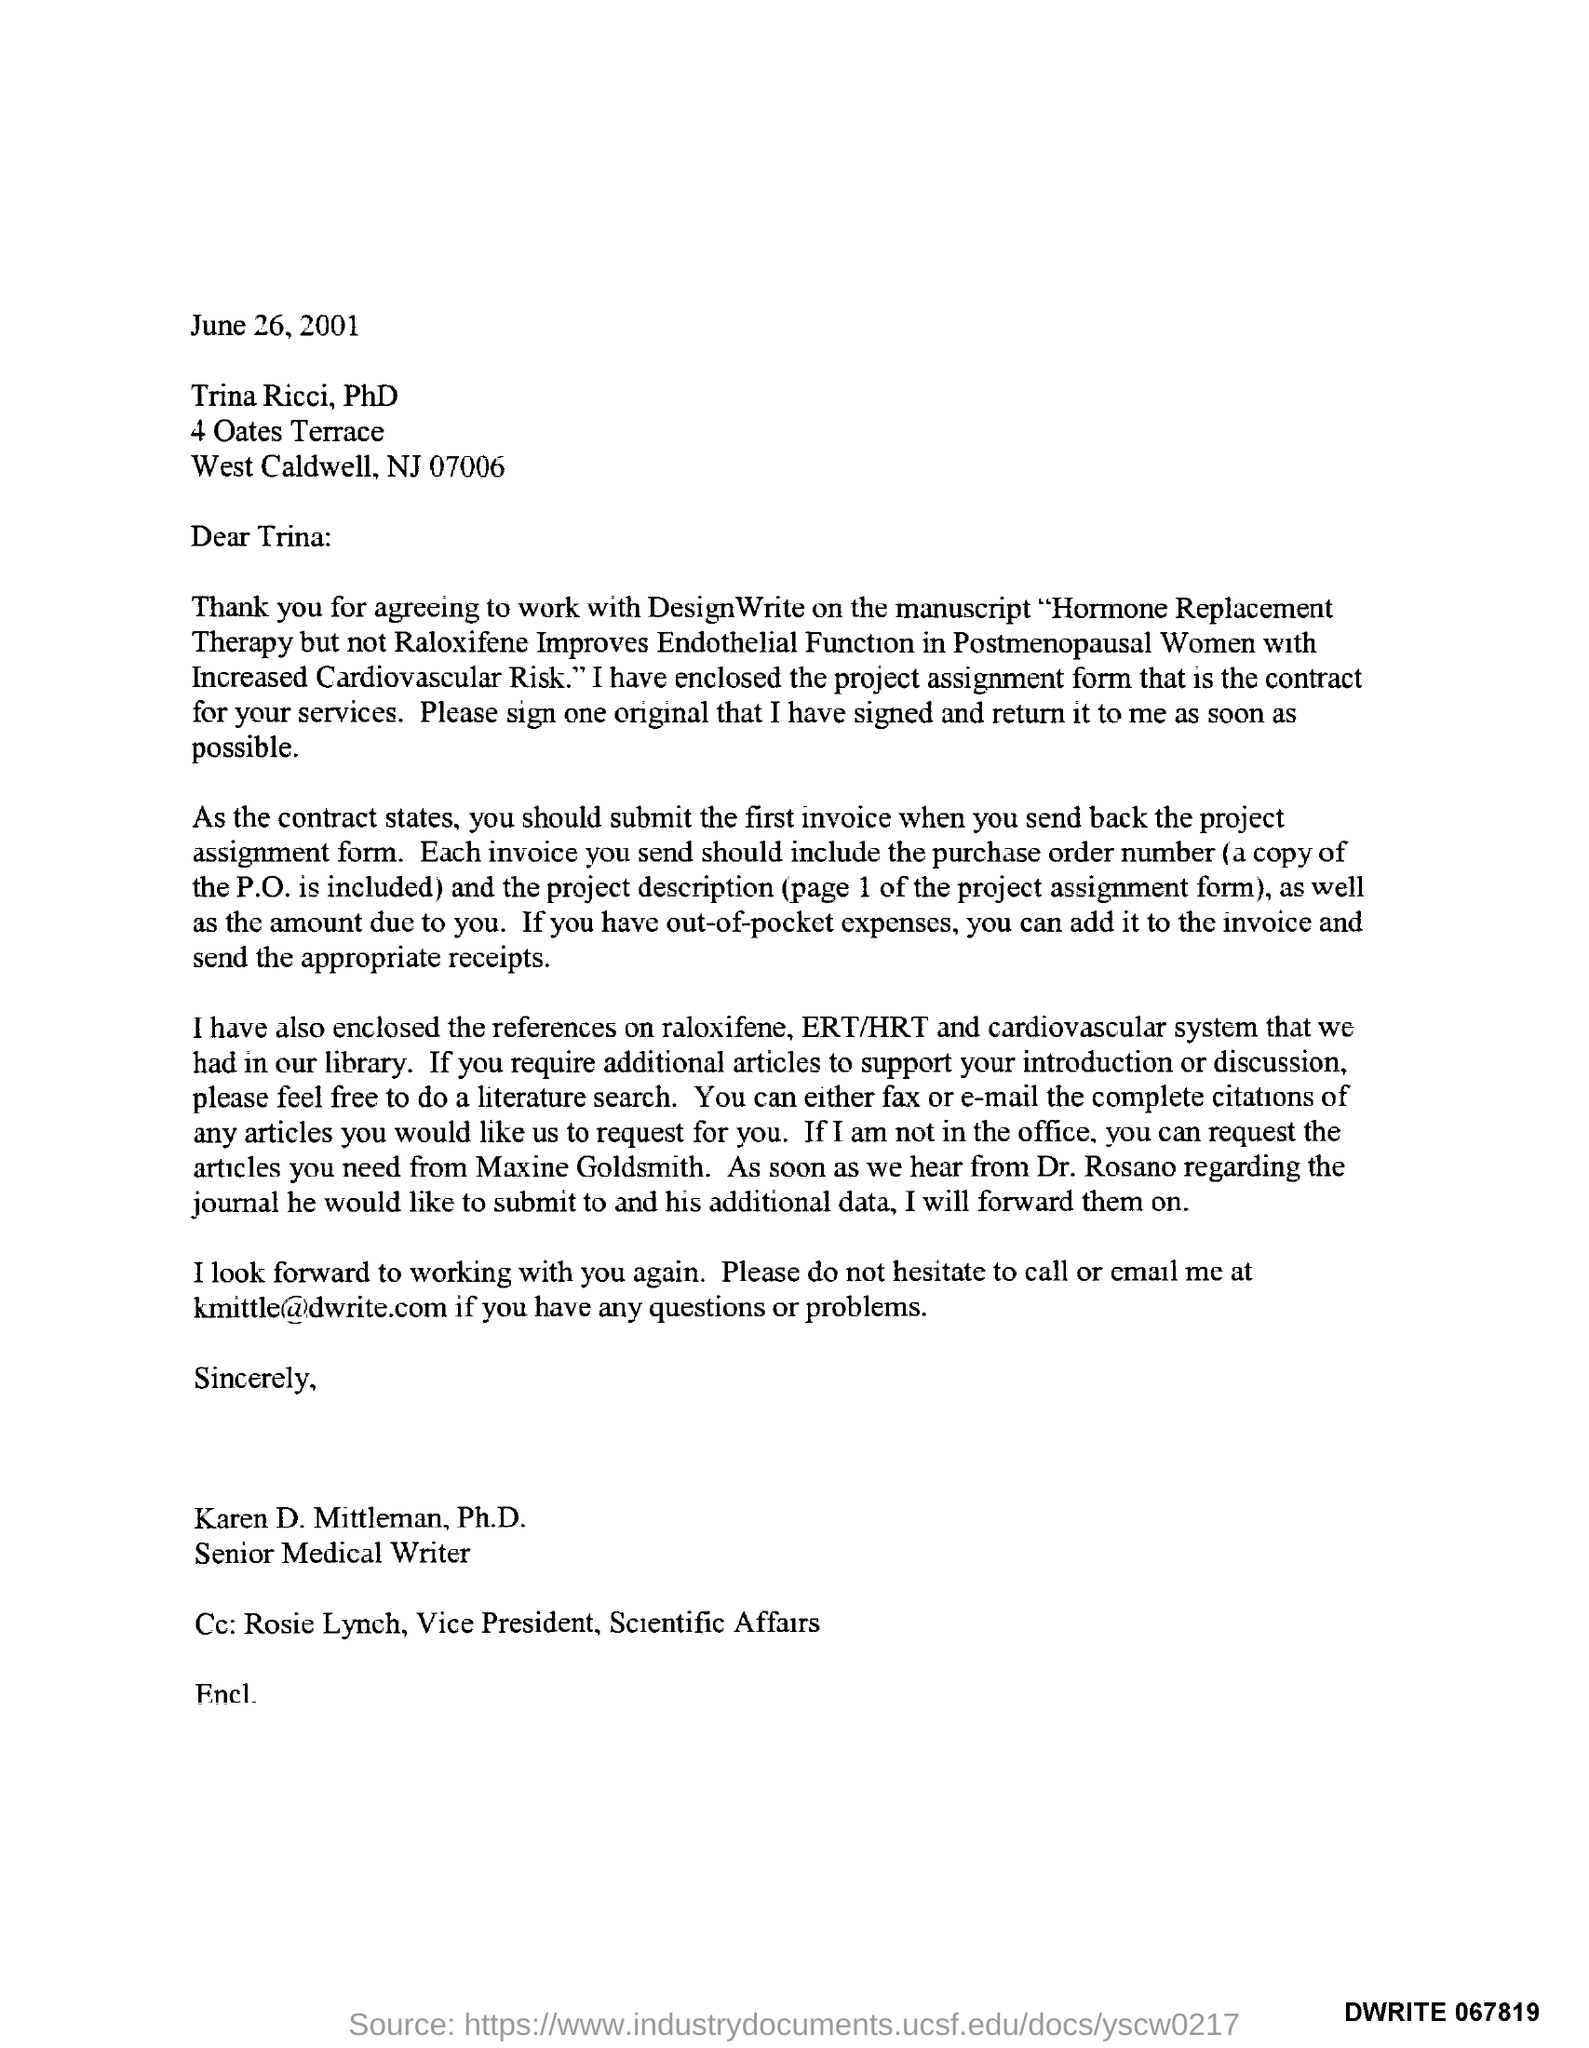What is the date mentioned in this letter?
Provide a short and direct response. June 26, 2001. Who is the sender of this letter?
Give a very brief answer. Karen D. Mittleman, Ph.D. What is the designation of Karen D. Mittleman, Ph.D.?
Your response must be concise. Senior Medical Writer. Who is marked in the cc of this letter?
Your answer should be very brief. Rosie Lynch, Vice President, Scientific Affairs. Who is the addressee of this letter?
Ensure brevity in your answer.  Trina Ricci, PhD. What is the email id of Karen D. Mittleman, Ph.D.?
Keep it short and to the point. Kmittle@dwrite.com. 